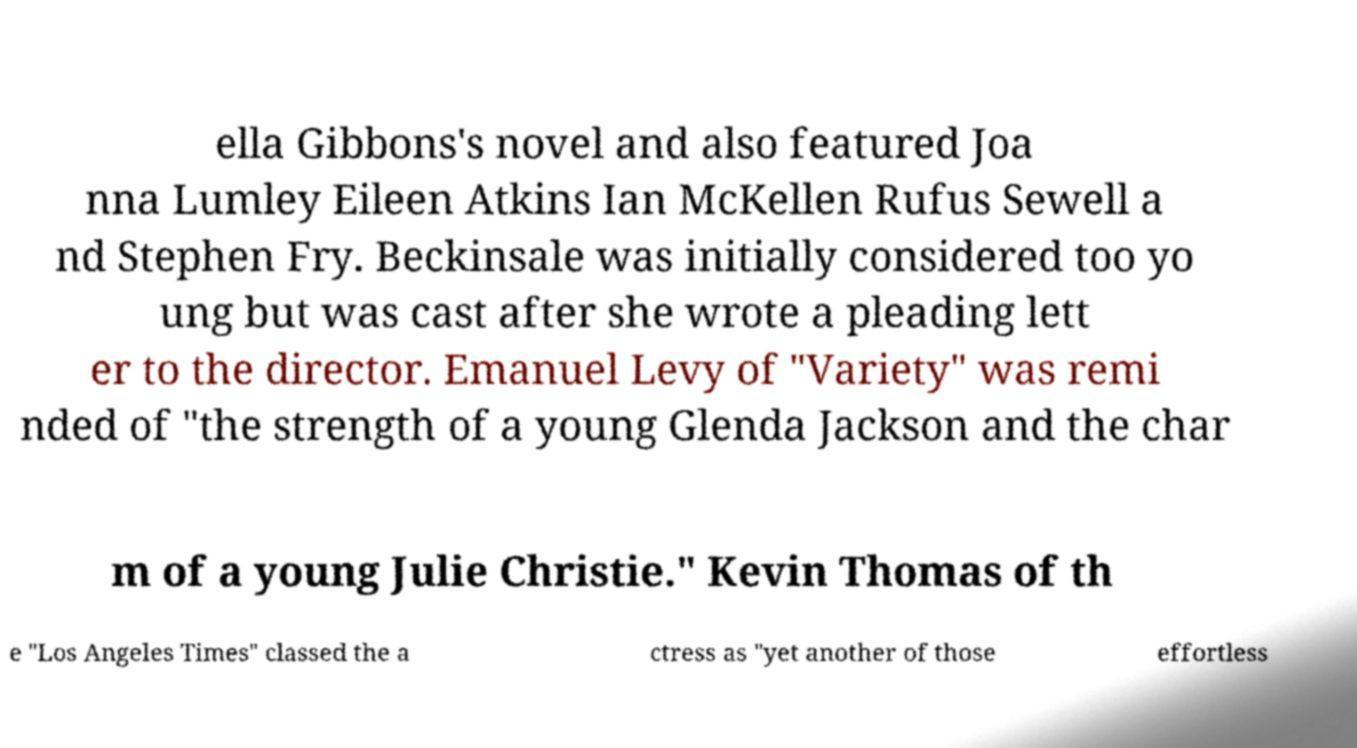There's text embedded in this image that I need extracted. Can you transcribe it verbatim? ella Gibbons's novel and also featured Joa nna Lumley Eileen Atkins Ian McKellen Rufus Sewell a nd Stephen Fry. Beckinsale was initially considered too yo ung but was cast after she wrote a pleading lett er to the director. Emanuel Levy of "Variety" was remi nded of "the strength of a young Glenda Jackson and the char m of a young Julie Christie." Kevin Thomas of th e "Los Angeles Times" classed the a ctress as "yet another of those effortless 